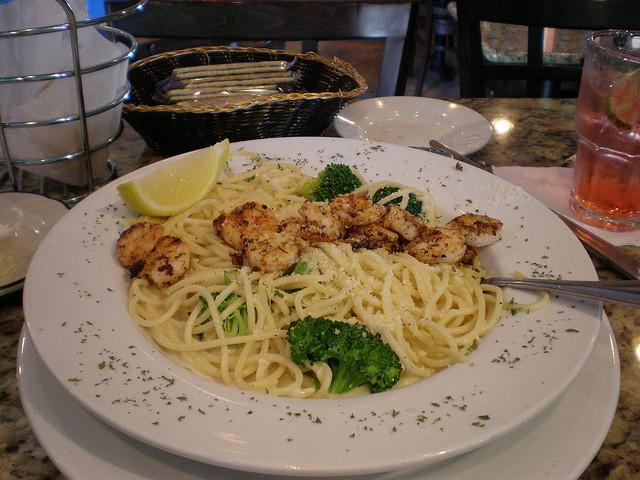What is in the spaghetti? shrimp 